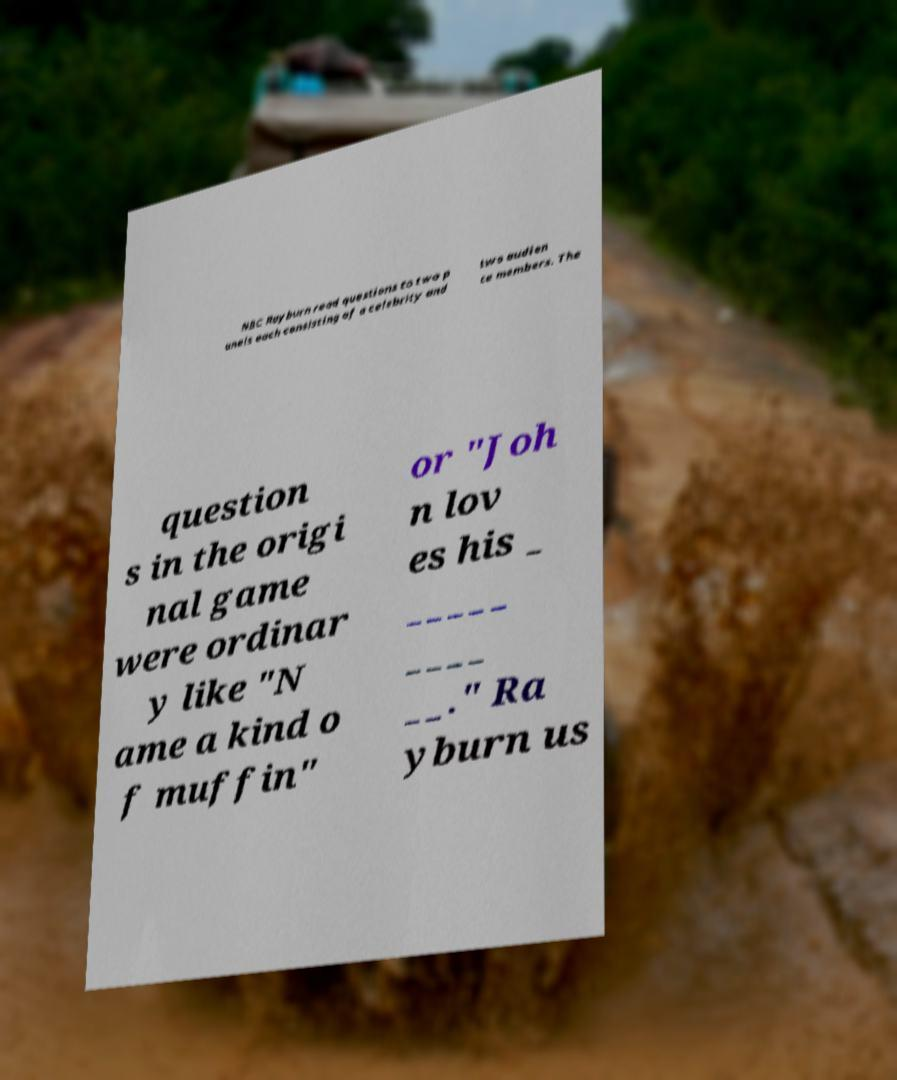Can you read and provide the text displayed in the image?This photo seems to have some interesting text. Can you extract and type it out for me? NBC Rayburn read questions to two p anels each consisting of a celebrity and two audien ce members. The question s in the origi nal game were ordinar y like "N ame a kind o f muffin" or "Joh n lov es his _ _____ ____ __." Ra yburn us 